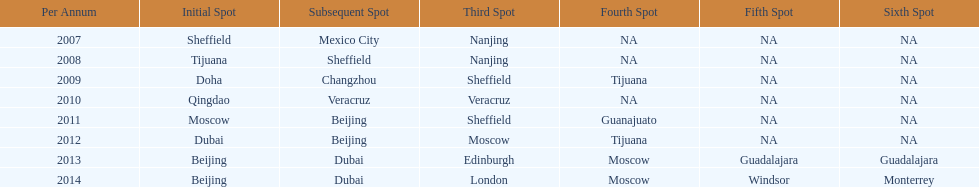Which year had more venues, 2007 or 2012? 2012. 